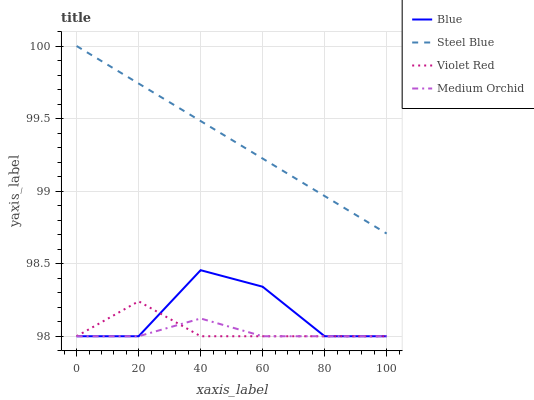Does Medium Orchid have the minimum area under the curve?
Answer yes or no. Yes. Does Steel Blue have the maximum area under the curve?
Answer yes or no. Yes. Does Violet Red have the minimum area under the curve?
Answer yes or no. No. Does Violet Red have the maximum area under the curve?
Answer yes or no. No. Is Steel Blue the smoothest?
Answer yes or no. Yes. Is Blue the roughest?
Answer yes or no. Yes. Is Violet Red the smoothest?
Answer yes or no. No. Is Violet Red the roughest?
Answer yes or no. No. Does Blue have the lowest value?
Answer yes or no. Yes. Does Steel Blue have the lowest value?
Answer yes or no. No. Does Steel Blue have the highest value?
Answer yes or no. Yes. Does Violet Red have the highest value?
Answer yes or no. No. Is Violet Red less than Steel Blue?
Answer yes or no. Yes. Is Steel Blue greater than Blue?
Answer yes or no. Yes. Does Violet Red intersect Blue?
Answer yes or no. Yes. Is Violet Red less than Blue?
Answer yes or no. No. Is Violet Red greater than Blue?
Answer yes or no. No. Does Violet Red intersect Steel Blue?
Answer yes or no. No. 